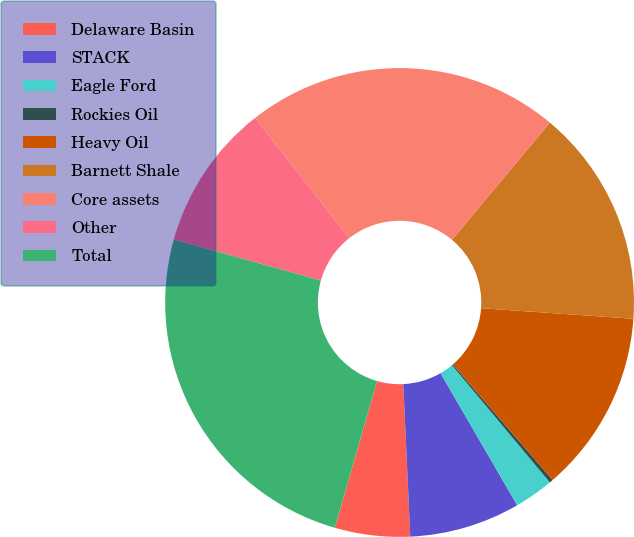Convert chart. <chart><loc_0><loc_0><loc_500><loc_500><pie_chart><fcel>Delaware Basin<fcel>STACK<fcel>Eagle Ford<fcel>Rockies Oil<fcel>Heavy Oil<fcel>Barnett Shale<fcel>Core assets<fcel>Other<fcel>Total<nl><fcel>5.18%<fcel>7.64%<fcel>2.71%<fcel>0.25%<fcel>12.57%<fcel>15.03%<fcel>21.65%<fcel>10.1%<fcel>24.88%<nl></chart> 